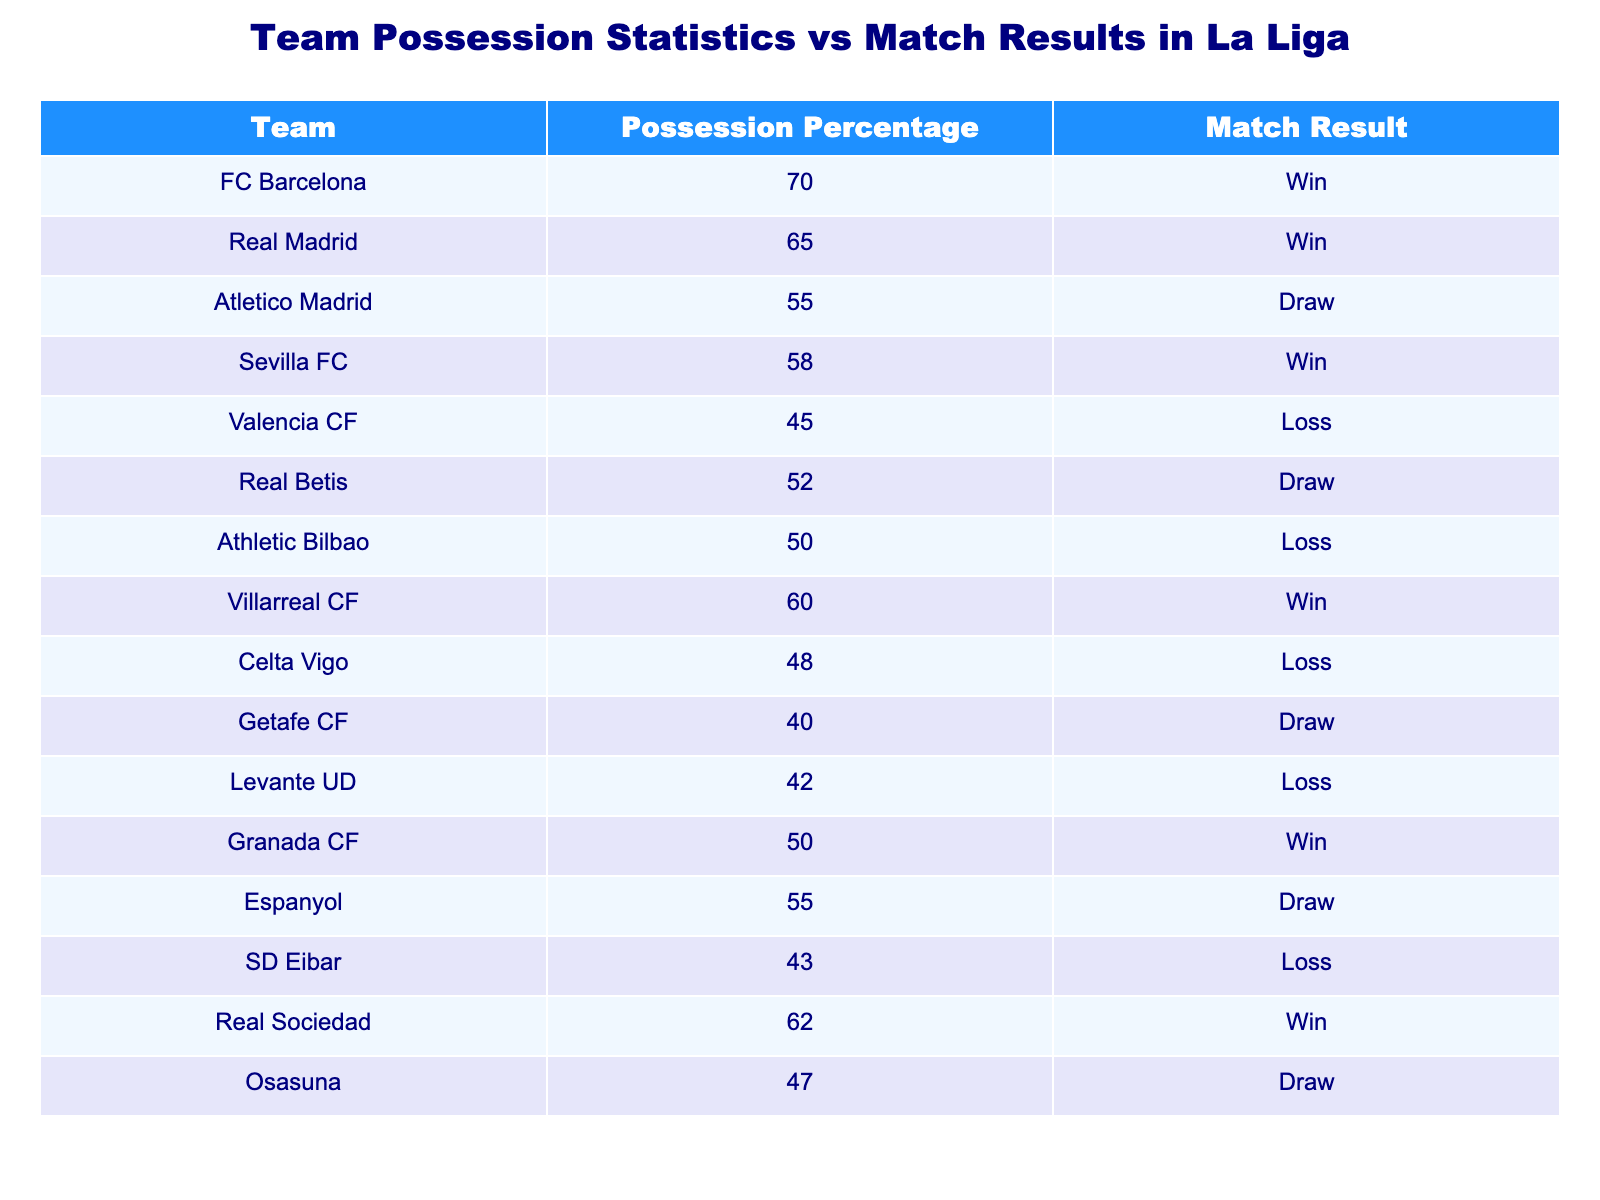What is the possession percentage of FC Barcelona? The table lists FC Barcelona with a possession percentage of 70, which is directly stated in the table.
Answer: 70 Which teams lost the match? By looking under the Match Result column, we see Valencia CF, Athletic Bilbao, Celta Vigo, Levante UD, SD Eibar who all have "Loss" as their result. These are the teams whose match results indicate a defeat.
Answer: Valencia CF, Athletic Bilbao, Celta Vigo, Levante UD, SD Eibar What is the average possession percentage of the teams that won? First, we collect the possession percentages of the teams that have "Win" in the Match Result column: FC Barcelona (70), Real Madrid (65), Sevilla FC (58), Villarreal CF (60), Granada CF (50), Real Sociedad (62). Then we sum these values: 70 + 65 + 58 + 60 + 50 + 62 = 365. There are 6 teams, so we divide 365 by 6, which equals about 60.83.
Answer: 60.83 Did any teams that had less than 50 possession percentage win the match? By checking the possession percentages of teams with "Win," we see that teams like FC Barcelona (70), Real Madrid (65), and so on have higher percentages, while no losing teams also managed to win. Therefore, the conclusion confirms that no teams with less than 50% possession won.
Answer: No What is the difference in possession percentage between the team with the highest possession and the team with the lowest possession? The highest possession percentage in the table is FC Barcelona with 70, while the lowest is Getafe CF with 40. To find the difference, we subtract the lowest from the highest: 70 - 40 = 30.
Answer: 30 How many teams drew their matches? By reviewing the Match Result column, we see that Atletico Madrid, Real Betis, Getafe CF, Espanyol, and Osasuna all have "Draw" listed as their result. Counting these rows, we find there are 5 teams that drew their matches.
Answer: 5 Which team had a possession percentage of 40 or less? From the table, we can see that Getafe CF is the only team that has a possession percentage of 40, confirming it meets the threshold.
Answer: Getafe CF Which teams had a Draw or Win result? In the Match Result column, we list teams with either "Draw" or "Win". This gives us Atletico Madrid, Real Betis, Sevilla FC, FC Barcelona, Real Madrid, Villarreal CF, Granada CF, Espanyol, SD Eibar, Osasuna, and Getafe CF, totaling 11 teams.
Answer: 11 